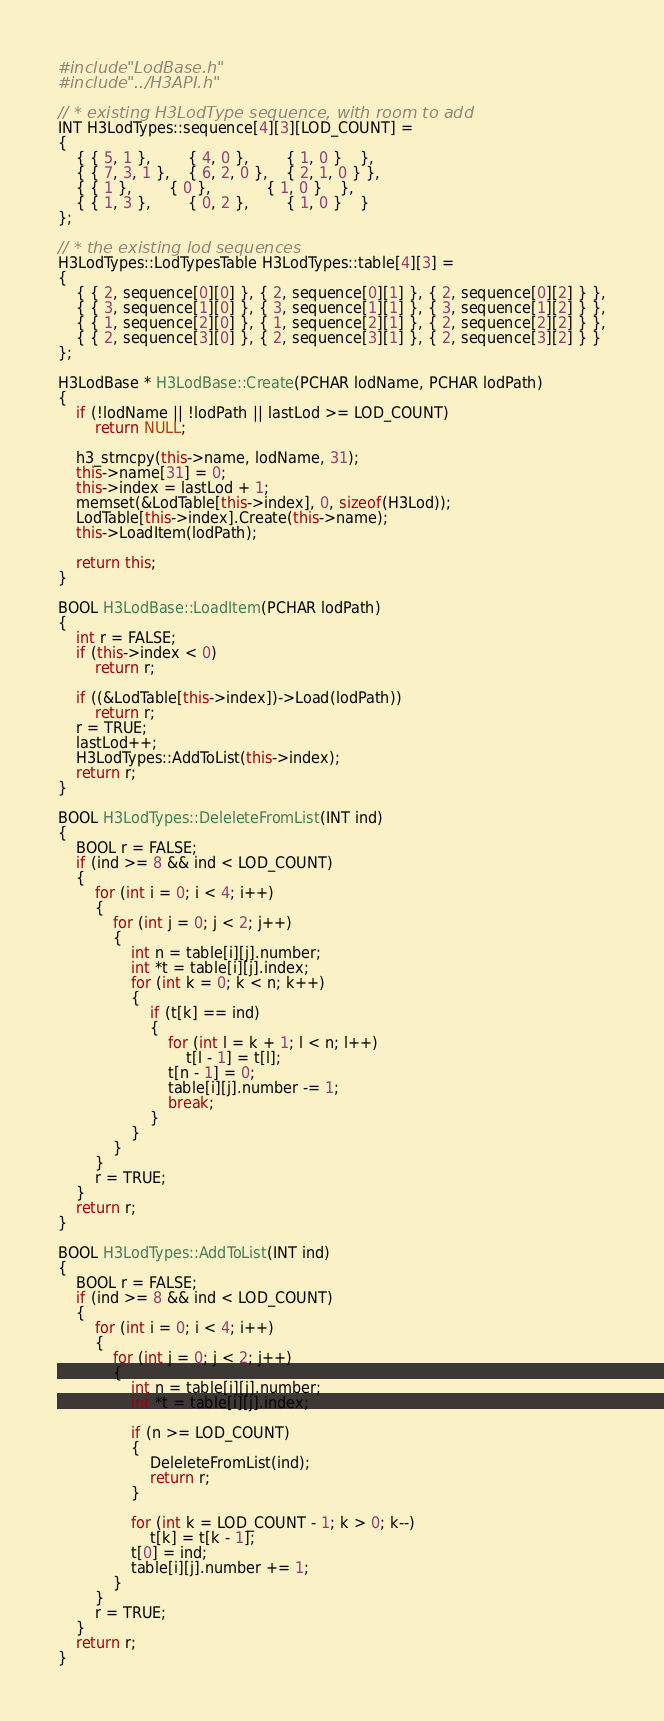<code> <loc_0><loc_0><loc_500><loc_500><_C++_>#include "LodBase.h"
#include "../H3API.h"

// * existing H3LodType sequence, with room to add
INT H3LodTypes::sequence[4][3][LOD_COUNT] =
{
	{ { 5, 1 },		{ 4, 0 },		{ 1, 0 }	},
	{ { 7, 3, 1 },	{ 6, 2, 0 },	{ 2, 1, 0 } },
	{ { 1 },		{ 0 },			{ 1, 0 }	},
	{ { 1, 3 },		{ 0, 2 },		{ 1, 0 }	}
};

// * the existing lod sequences
H3LodTypes::LodTypesTable H3LodTypes::table[4][3] =
{
	{ { 2, sequence[0][0] }, { 2, sequence[0][1] }, { 2, sequence[0][2] } },
	{ { 3, sequence[1][0] }, { 3, sequence[1][1] }, { 3, sequence[1][2] } },
	{ { 1, sequence[2][0] }, { 1, sequence[2][1] }, { 2, sequence[2][2] } },
	{ { 2, sequence[3][0] }, { 2, sequence[3][1] }, { 2, sequence[3][2] } }
};

H3LodBase * H3LodBase::Create(PCHAR lodName, PCHAR lodPath)
{
	if (!lodName || !lodPath || lastLod >= LOD_COUNT)
		return NULL;

	h3_strncpy(this->name, lodName, 31);
	this->name[31] = 0;
	this->index = lastLod + 1;
	memset(&LodTable[this->index], 0, sizeof(H3Lod));
	LodTable[this->index].Create(this->name);
	this->LoadItem(lodPath);

	return this;
}

BOOL H3LodBase::LoadItem(PCHAR lodPath)
{
	int r = FALSE;
	if (this->index < 0)
		return r;

	if ((&LodTable[this->index])->Load(lodPath))
		return r;
	r = TRUE;
	lastLod++;
	H3LodTypes::AddToList(this->index);
	return r;
}

BOOL H3LodTypes::DeleleteFromList(INT ind)
{
	BOOL r = FALSE;
	if (ind >= 8 && ind < LOD_COUNT)
	{
		for (int i = 0; i < 4; i++)
		{
			for (int j = 0; j < 2; j++)
			{
				int n = table[i][j].number;
				int *t = table[i][j].index;
				for (int k = 0; k < n; k++)
				{
					if (t[k] == ind)
					{
						for (int l = k + 1; l < n; l++)
							t[l - 1] = t[l];
						t[n - 1] = 0;
						table[i][j].number -= 1;
						break;
					}
				}
			}
		}
		r = TRUE;
	}
	return r;
}

BOOL H3LodTypes::AddToList(INT ind)
{
	BOOL r = FALSE;
	if (ind >= 8 && ind < LOD_COUNT)
	{
		for (int i = 0; i < 4; i++)
		{
			for (int j = 0; j < 2; j++)
			{
				int n = table[i][j].number;
				int *t = table[i][j].index;

				if (n >= LOD_COUNT)
				{
					DeleleteFromList(ind);
					return r;
				}

				for (int k = LOD_COUNT - 1; k > 0; k--)
					t[k] = t[k - 1];
				t[0] = ind;
				table[i][j].number += 1;
			}
		}
		r = TRUE;
	}
	return r;
}</code> 